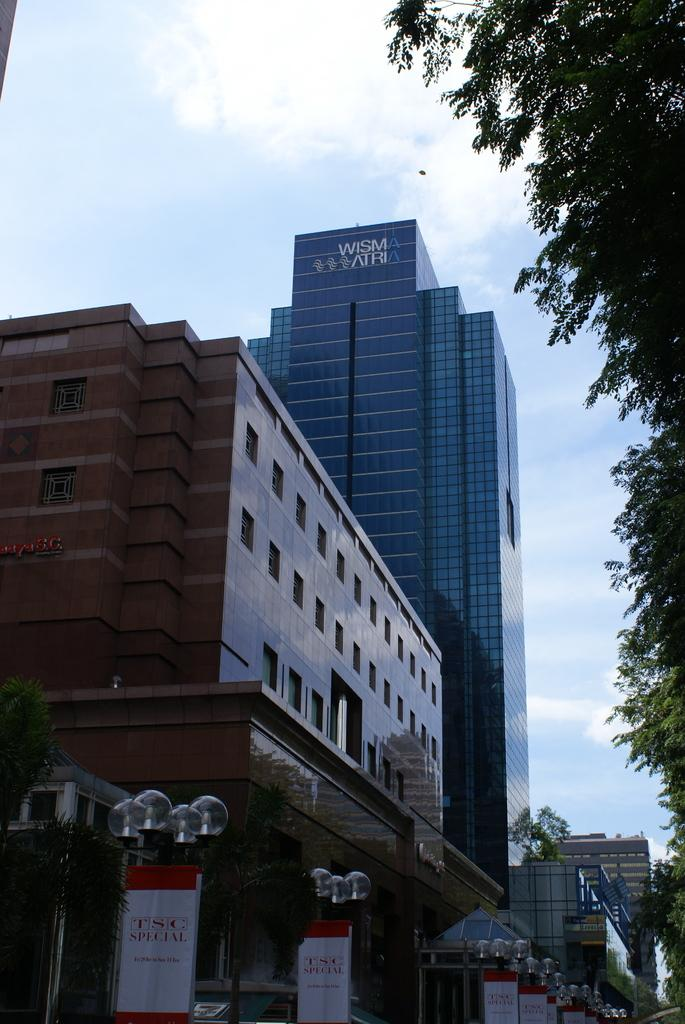<image>
Write a terse but informative summary of the picture. A tall black building owned by Wisma Atria. 